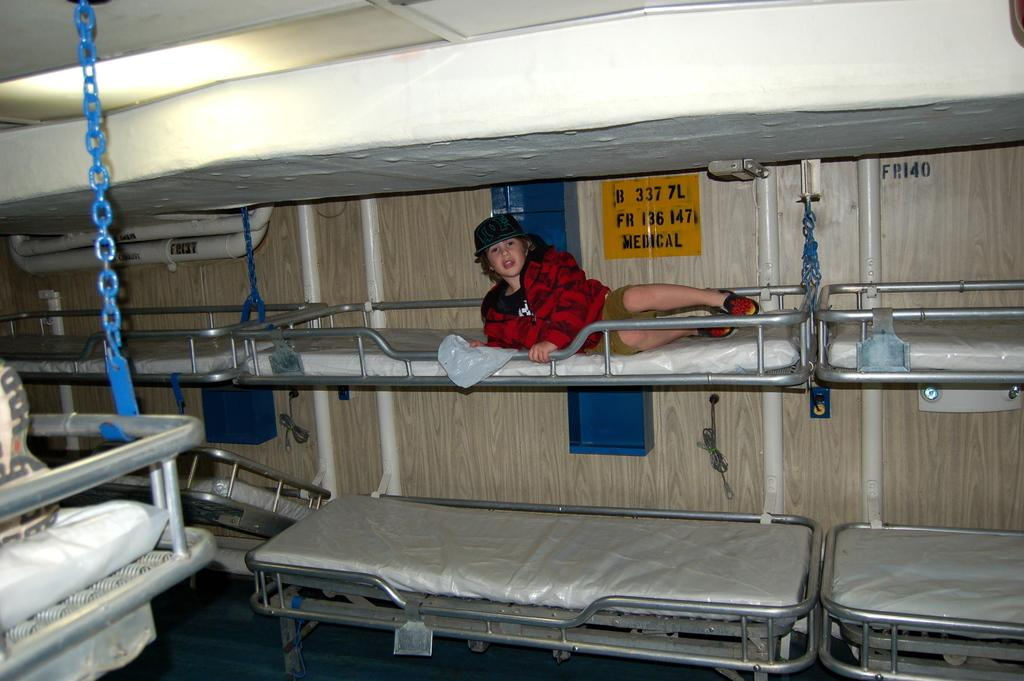What is the kid doing in the image? The kid is laying on the bed in the image. Where might this image have been taken? The setting appears to be a dormitory. What can be seen in the background of the image? There is a wall visible in the background of the image. What thought does the kid have about the approval of their desire in the image? There is no indication of the kid's thoughts or desires in the image, as it only shows the kid laying on the bed in a dormitory setting. 